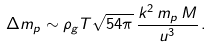<formula> <loc_0><loc_0><loc_500><loc_500>\Delta m _ { p } \sim \rho _ { g } T \sqrt { 5 4 \pi } \, \frac { k ^ { 2 } \, m _ { p } \, M } { u ^ { 3 } } \, .</formula> 